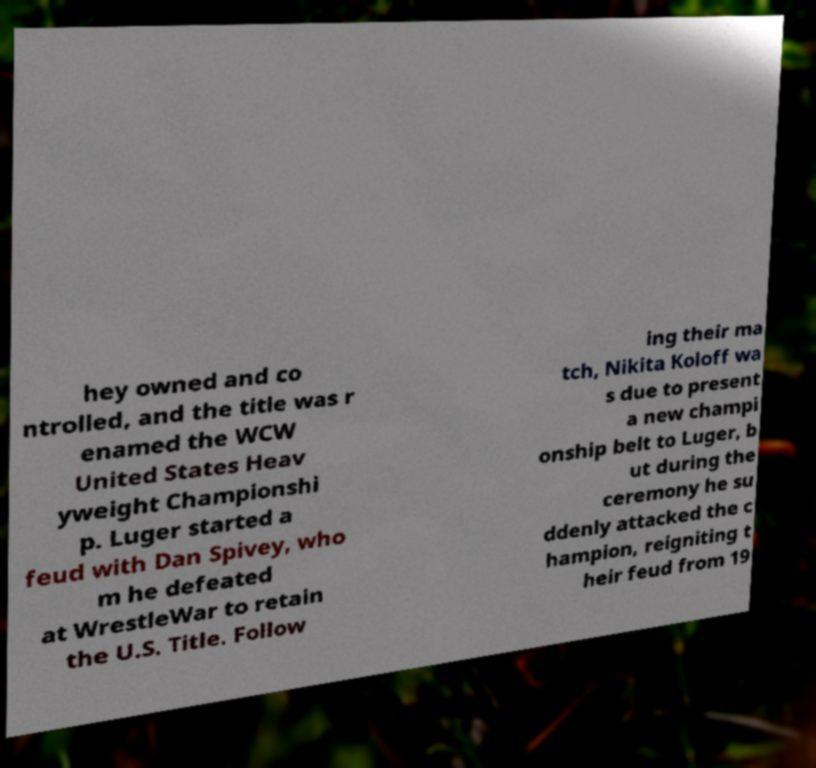Can you accurately transcribe the text from the provided image for me? hey owned and co ntrolled, and the title was r enamed the WCW United States Heav yweight Championshi p. Luger started a feud with Dan Spivey, who m he defeated at WrestleWar to retain the U.S. Title. Follow ing their ma tch, Nikita Koloff wa s due to present a new champi onship belt to Luger, b ut during the ceremony he su ddenly attacked the c hampion, reigniting t heir feud from 19 